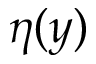<formula> <loc_0><loc_0><loc_500><loc_500>\eta ( y )</formula> 